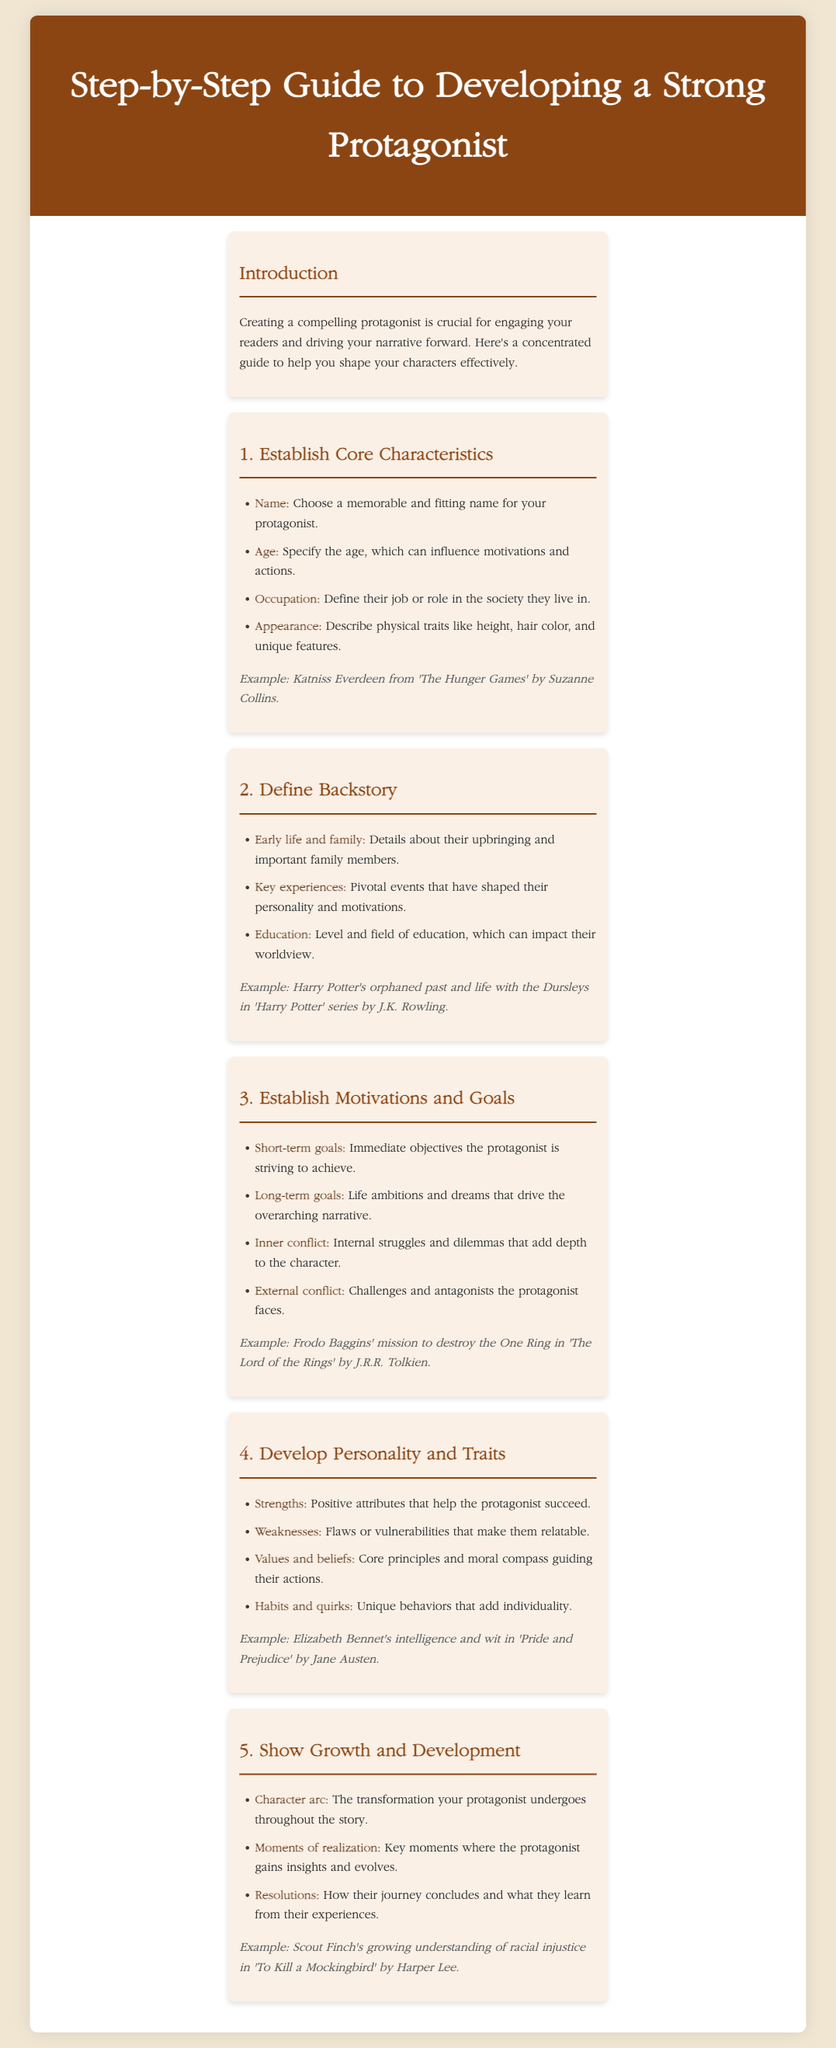What is the title of the guide? The title is provided in the header section of the document, which introduces the main topic of the infographic.
Answer: Step-by-Step Guide to Developing a Strong Protagonist What is the first step in developing a strong protagonist? The first step is listed as the primary section under the character development process, detailing initial actions to define characters.
Answer: Establish Core Characteristics Who is an example of a specific protagonist mentioned? The document provides illustrative examples of characters from well-known literature to support discussion points.
Answer: Katniss Everdeen What is one core principle guiding a protagonist's actions? Key principles and beliefs that shape a character's decisions are outlined under the personality and traits development section.
Answer: Values and beliefs What type of conflict is described as internal? The document distinguishes between different types of conflicts affecting the protagonist, and this one specifically relates to personal struggles.
Answer: Inner conflict How many main steps are outlined for developing a protagonist? The document is structured into a series of distinct steps, each addressing a specific aspect of character development.
Answer: Five What character arc transformation is a protagonist expected to undergo? This transformation reflects the overarching growth that a character experiences throughout their story arc.
Answer: Character arc What is the example provided for showing growth and development? Specific literary characters are mentioned as examples to illustrate key points in the development framework.
Answer: Scout Finch's growing understanding of racial injustice 